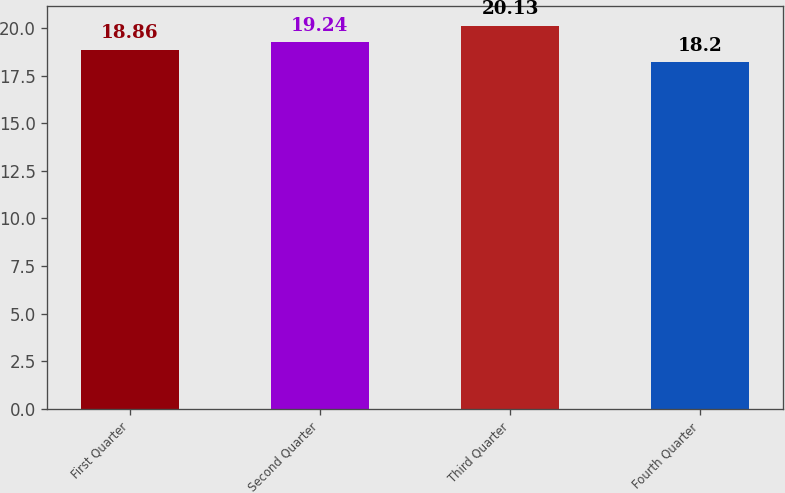Convert chart. <chart><loc_0><loc_0><loc_500><loc_500><bar_chart><fcel>First Quarter<fcel>Second Quarter<fcel>Third Quarter<fcel>Fourth Quarter<nl><fcel>18.86<fcel>19.24<fcel>20.13<fcel>18.2<nl></chart> 